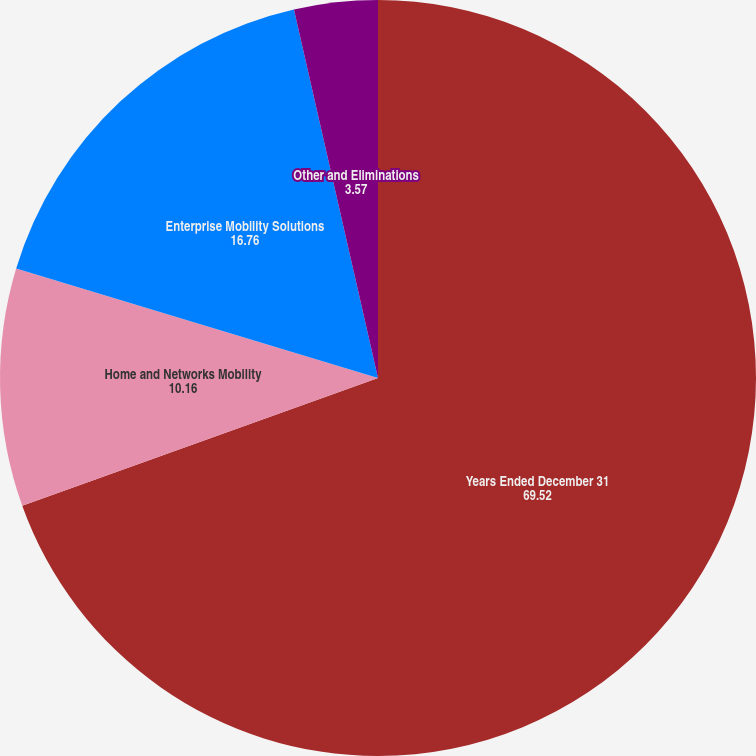Convert chart to OTSL. <chart><loc_0><loc_0><loc_500><loc_500><pie_chart><fcel>Years Ended December 31<fcel>Home and Networks Mobility<fcel>Enterprise Mobility Solutions<fcel>Other and Eliminations<nl><fcel>69.52%<fcel>10.16%<fcel>16.76%<fcel>3.57%<nl></chart> 